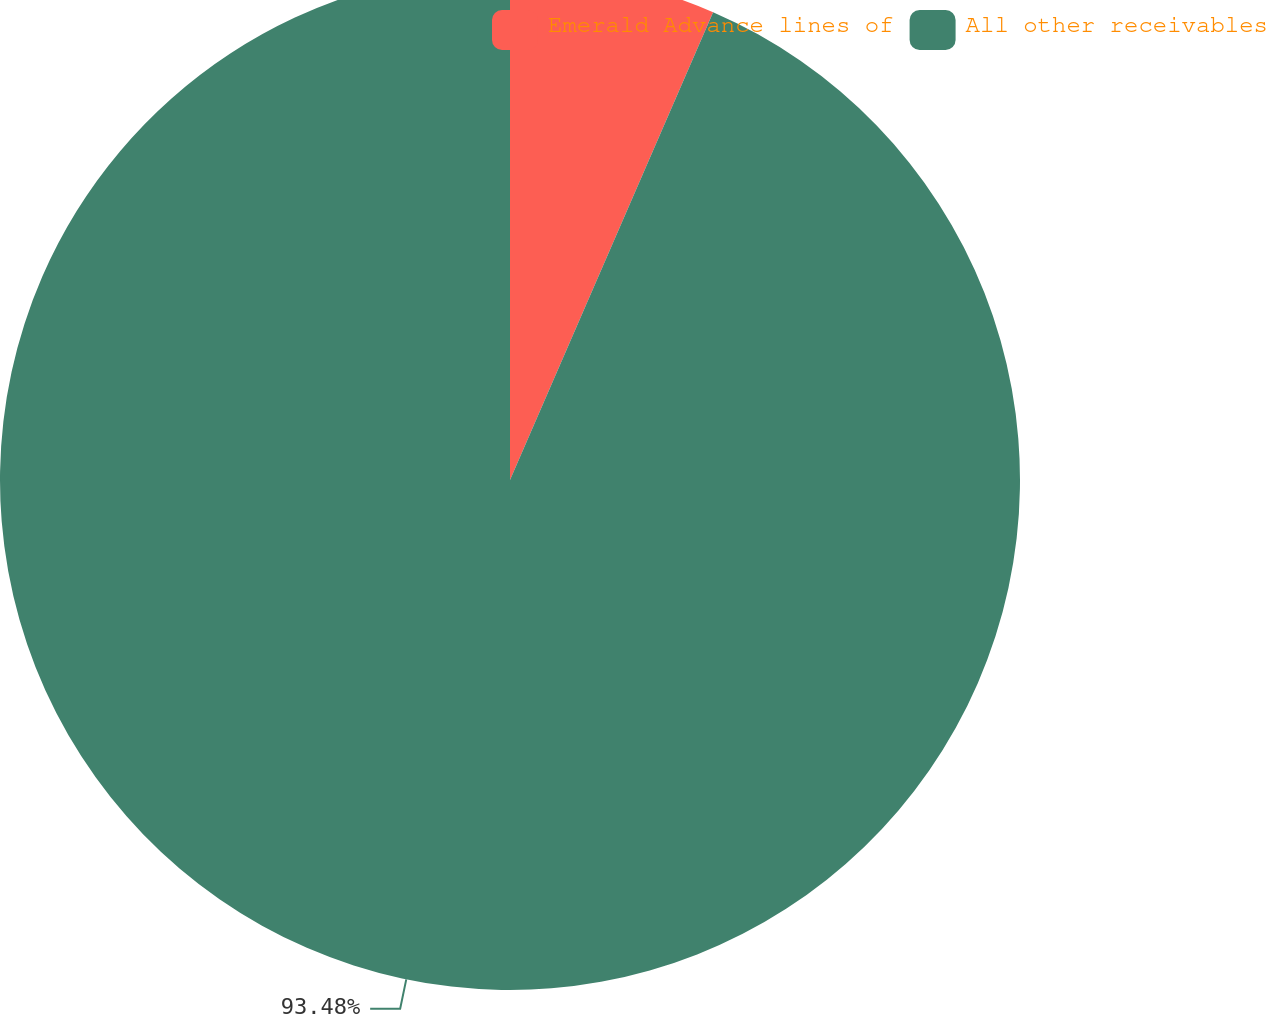Convert chart to OTSL. <chart><loc_0><loc_0><loc_500><loc_500><pie_chart><fcel>Emerald Advance lines of<fcel>All other receivables<nl><fcel>6.52%<fcel>93.48%<nl></chart> 